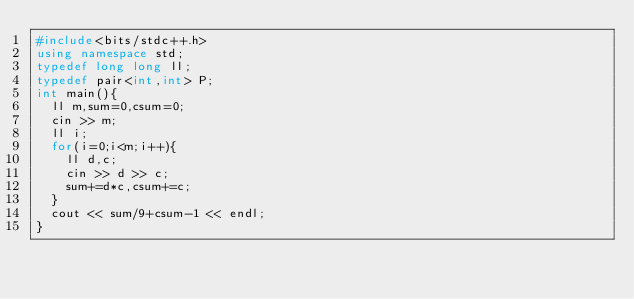<code> <loc_0><loc_0><loc_500><loc_500><_C++_>#include<bits/stdc++.h>
using namespace std;
typedef long long ll;
typedef pair<int,int> P;
int main(){
  ll m,sum=0,csum=0;
  cin >> m;
  ll i;
  for(i=0;i<m;i++){
    ll d,c;
    cin >> d >> c;
    sum+=d*c,csum+=c;
  }
  cout << sum/9+csum-1 << endl;
}</code> 